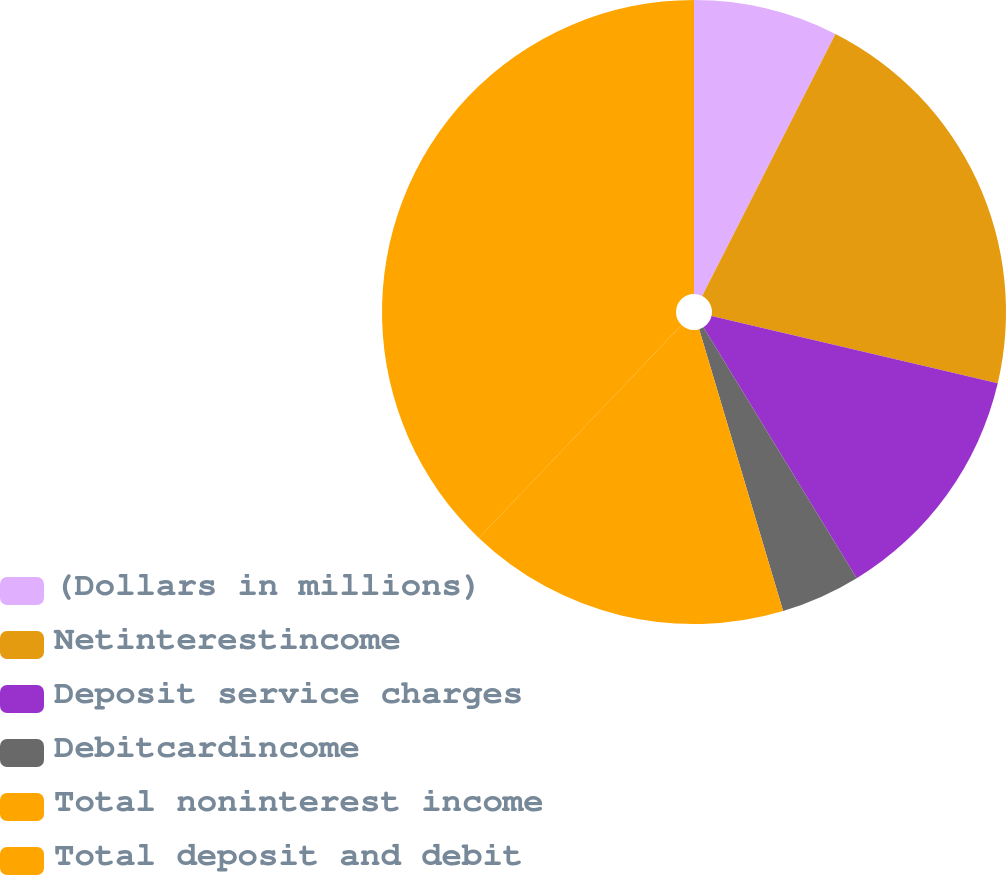Convert chart to OTSL. <chart><loc_0><loc_0><loc_500><loc_500><pie_chart><fcel>(Dollars in millions)<fcel>Netinterestincome<fcel>Deposit service charges<fcel>Debitcardincome<fcel>Total noninterest income<fcel>Total deposit and debit<nl><fcel>7.49%<fcel>21.18%<fcel>12.6%<fcel>4.12%<fcel>16.72%<fcel>37.89%<nl></chart> 